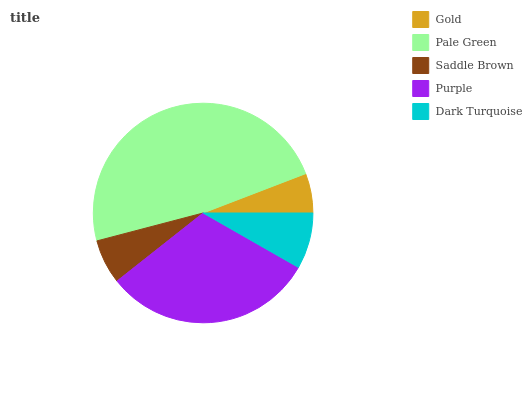Is Gold the minimum?
Answer yes or no. Yes. Is Pale Green the maximum?
Answer yes or no. Yes. Is Saddle Brown the minimum?
Answer yes or no. No. Is Saddle Brown the maximum?
Answer yes or no. No. Is Pale Green greater than Saddle Brown?
Answer yes or no. Yes. Is Saddle Brown less than Pale Green?
Answer yes or no. Yes. Is Saddle Brown greater than Pale Green?
Answer yes or no. No. Is Pale Green less than Saddle Brown?
Answer yes or no. No. Is Dark Turquoise the high median?
Answer yes or no. Yes. Is Dark Turquoise the low median?
Answer yes or no. Yes. Is Pale Green the high median?
Answer yes or no. No. Is Saddle Brown the low median?
Answer yes or no. No. 